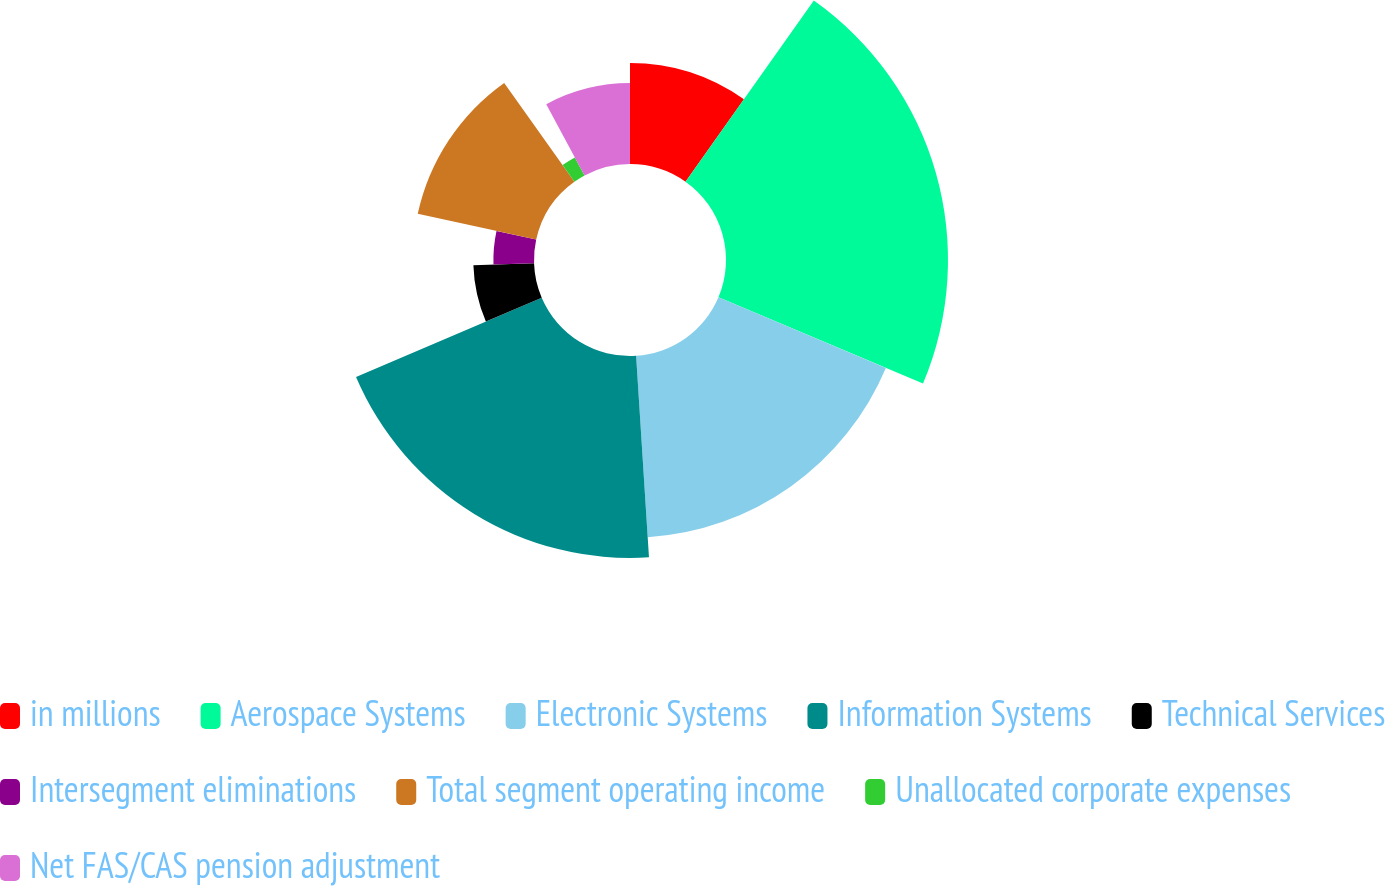Convert chart to OTSL. <chart><loc_0><loc_0><loc_500><loc_500><pie_chart><fcel>in millions<fcel>Aerospace Systems<fcel>Electronic Systems<fcel>Information Systems<fcel>Technical Services<fcel>Intersegment eliminations<fcel>Total segment operating income<fcel>Unallocated corporate expenses<fcel>Net FAS/CAS pension adjustment<nl><fcel>9.81%<fcel>21.54%<fcel>17.63%<fcel>19.59%<fcel>5.89%<fcel>3.94%<fcel>11.76%<fcel>1.98%<fcel>7.85%<nl></chart> 